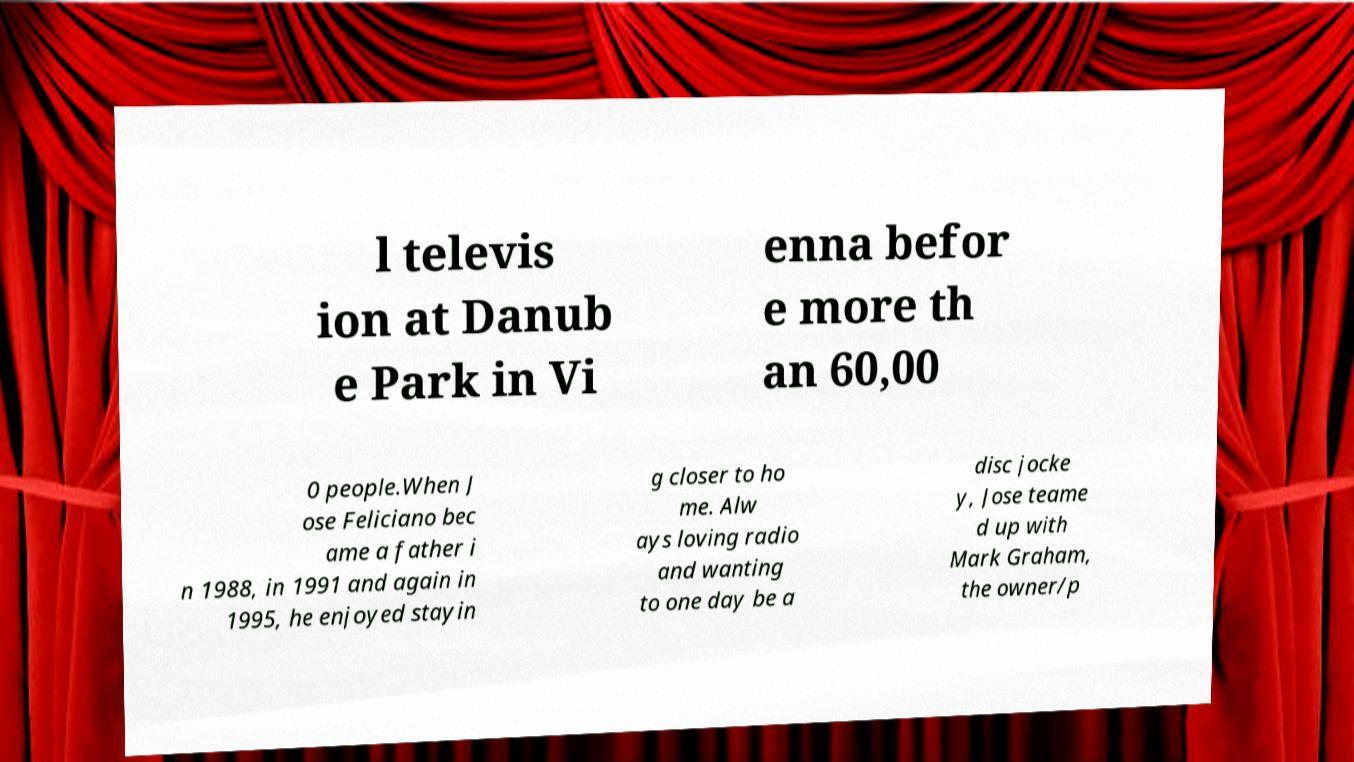There's text embedded in this image that I need extracted. Can you transcribe it verbatim? l televis ion at Danub e Park in Vi enna befor e more th an 60,00 0 people.When J ose Feliciano bec ame a father i n 1988, in 1991 and again in 1995, he enjoyed stayin g closer to ho me. Alw ays loving radio and wanting to one day be a disc jocke y, Jose teame d up with Mark Graham, the owner/p 